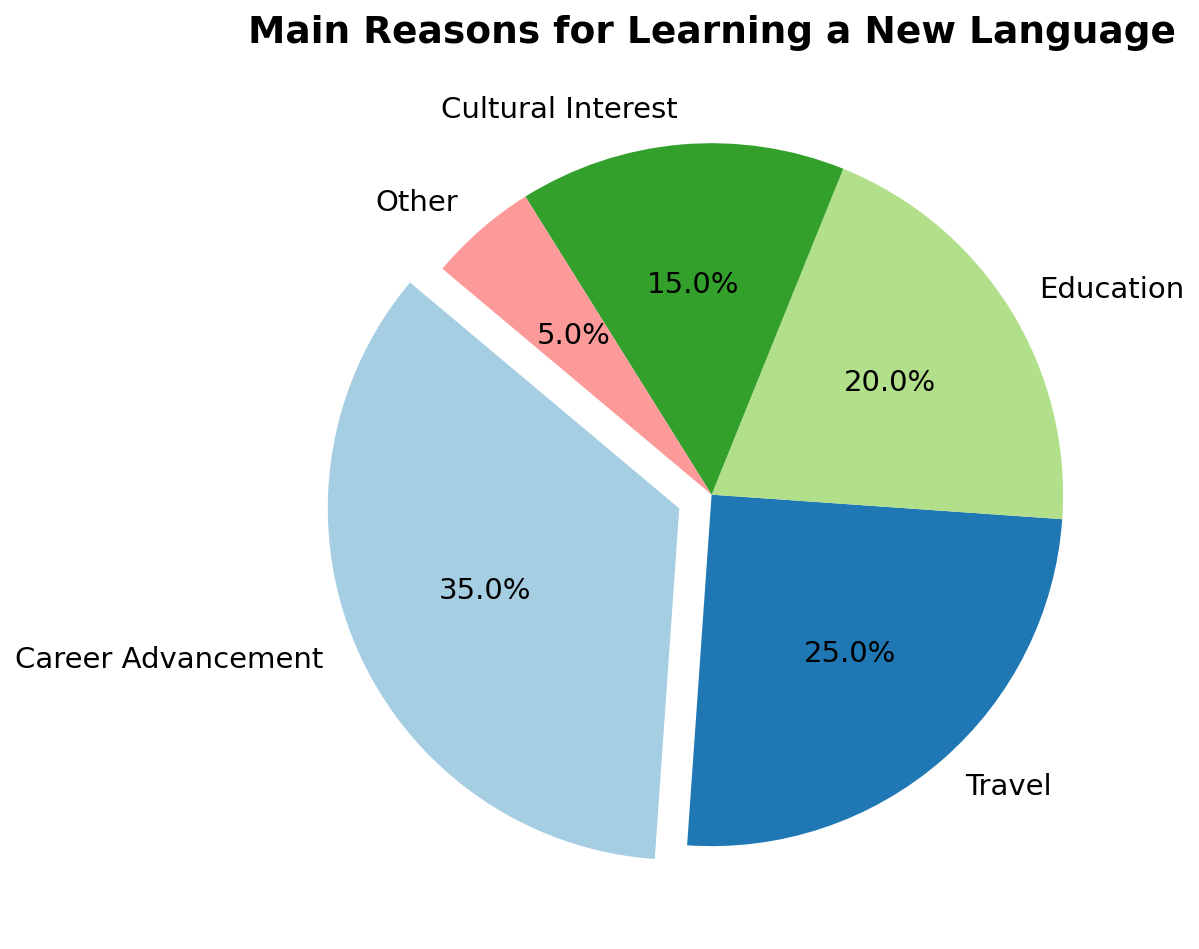Which category has the highest percentage? The pie chart indicates percentages for each category. "Career Advancement" stands out as the largest segment with 35%.
Answer: Career Advancement What's the combined percentage of people learning a language for Travel and Cultural Interest? To find the combined percentage, sum the percentages for "Travel" and "Cultural Interest". Travel is 25% and Cultural Interest is 15%, so their sum is 25% + 15% = 40%.
Answer: 40% What's the percentage difference between Education and Other? Subtract the percentage for "Other" from the percentage for "Education". Education is 20% and Other is 5%, so the difference is 20% - 5% = 15%.
Answer: 15% Which categories together make up 60% of the reasons for learning a new language? To find which categories make up 60%, add the percentages of the categories starting from the highest. Career Advancement (35%) + Travel (25%) sums to 60%.
Answer: Career Advancement and Travel If you combine the percentages for Education and Cultural Interest, does it exceed the percentage for Career Advancement? Calculate the combined percentage for Education (20%) and Cultural Interest (15%), which is 20% + 15% = 35%. This is equal to the percentage for Career Advancement (35%), not exceeding it.
Answer: No Which category's segment visually appears to be the smallest in the pie chart? The segment for the category with the smallest percentage will appear the smallest visually. The "Other" category at 5% is the smallest.
Answer: Other How much larger is the Career Advancement segment compared to the Travel segment? Subtract the percentage for Travel from the percentage for Career Advancement. Career Advancement is 35%, Travel is 25%, so the difference is 35% - 25% = 10%.
Answer: 10% What is the color of the segment representing Cultural Interest in the pie chart? The segments are colored using a different color from a specific colormap. Observing the chart, we identify the color designated for Cultural Interest, which is distinctly different from the others.
Answer: [Color assigned to Cultural Interest] List the categories in ascending order of their percentage. Arrange the categories based on their percentages from smallest to largest. Other (5%), Cultural Interest (15%), Education (20%), Travel (25%), Career Advancement (35%).
Answer: Other, Cultural Interest, Education, Travel, Career Advancement Which two categories together have the same percentage as the Education category? Identify two categories whose combined percentages equal that of Education (20%). Combining Cultural Interest (15%) and Other (5%) gives 15% + 5% = 20%.
Answer: Cultural Interest and Other 